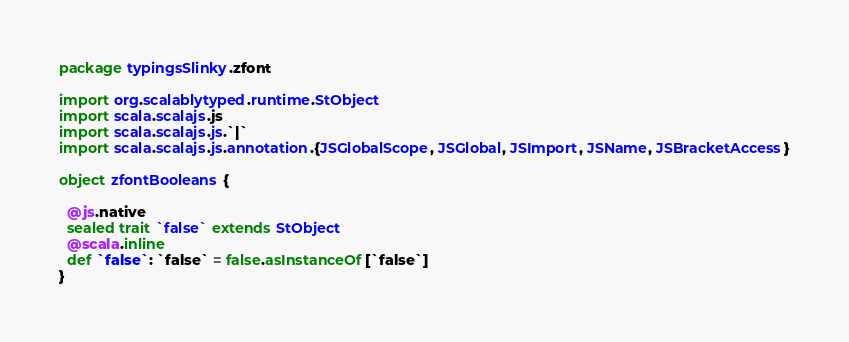<code> <loc_0><loc_0><loc_500><loc_500><_Scala_>package typingsSlinky.zfont

import org.scalablytyped.runtime.StObject
import scala.scalajs.js
import scala.scalajs.js.`|`
import scala.scalajs.js.annotation.{JSGlobalScope, JSGlobal, JSImport, JSName, JSBracketAccess}

object zfontBooleans {
  
  @js.native
  sealed trait `false` extends StObject
  @scala.inline
  def `false`: `false` = false.asInstanceOf[`false`]
}
</code> 